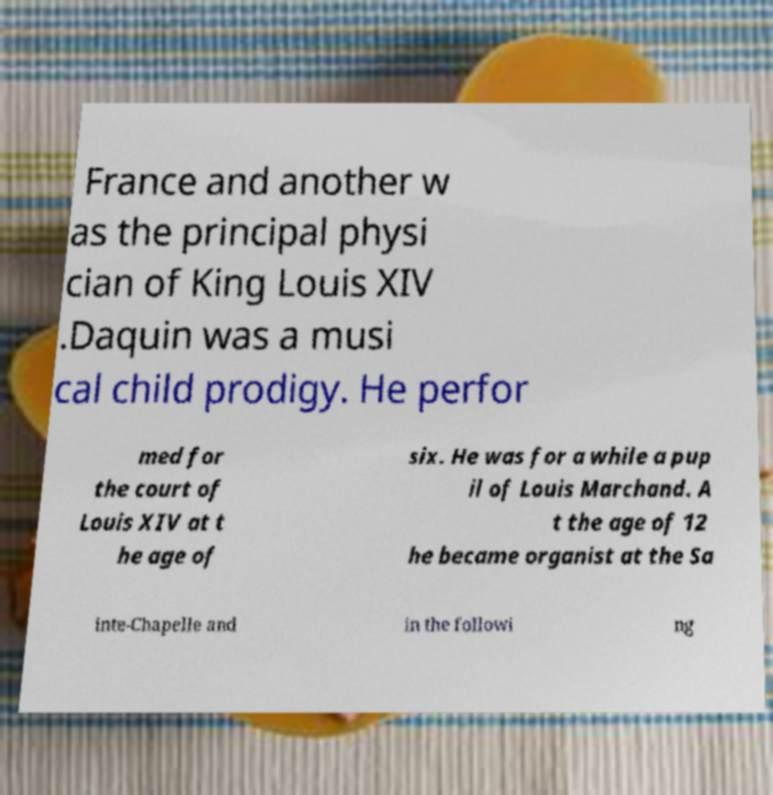Can you read and provide the text displayed in the image?This photo seems to have some interesting text. Can you extract and type it out for me? France and another w as the principal physi cian of King Louis XIV .Daquin was a musi cal child prodigy. He perfor med for the court of Louis XIV at t he age of six. He was for a while a pup il of Louis Marchand. A t the age of 12 he became organist at the Sa inte-Chapelle and in the followi ng 